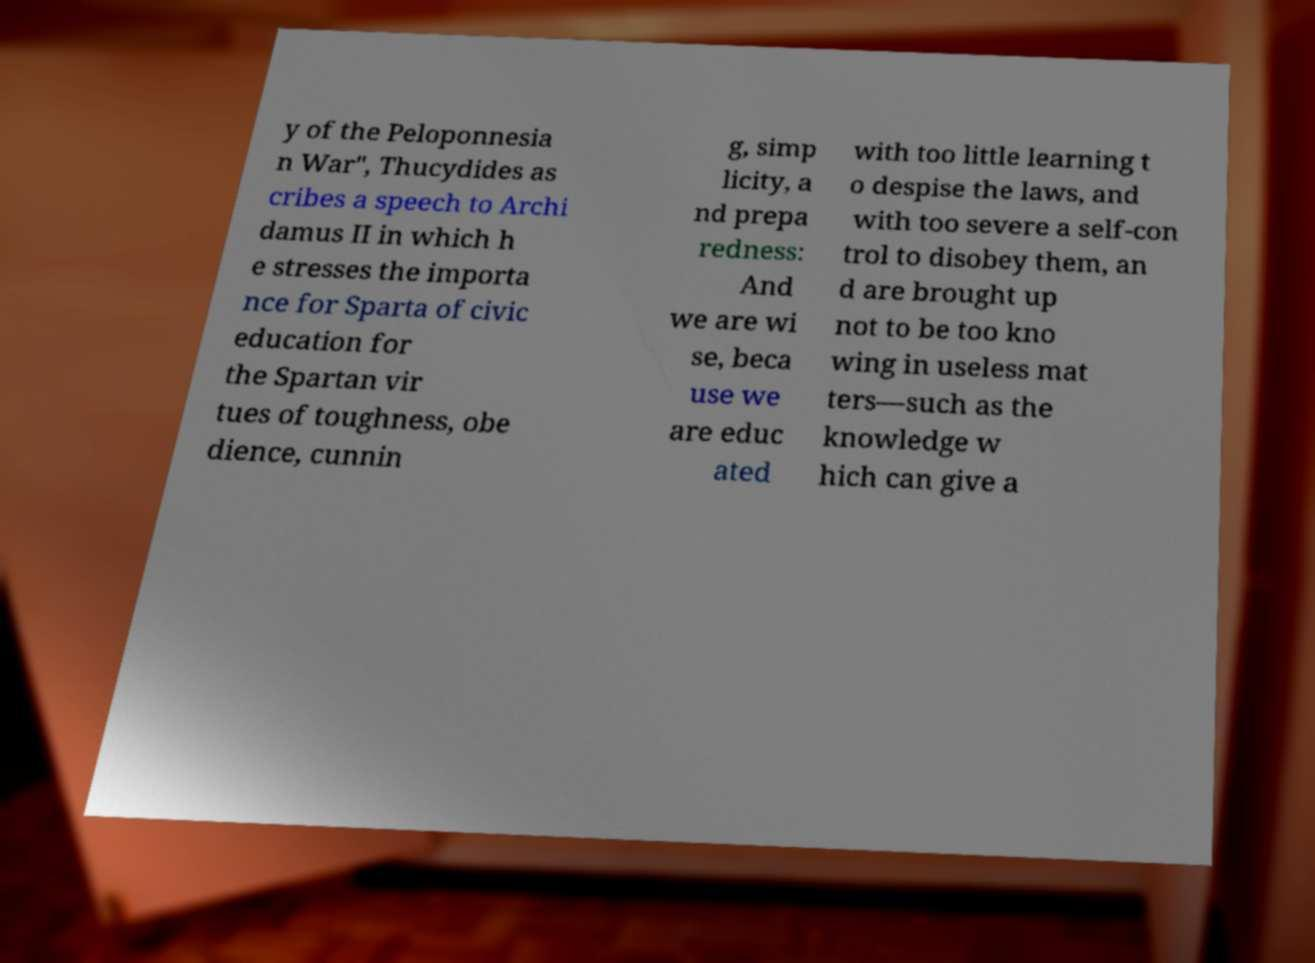Can you read and provide the text displayed in the image?This photo seems to have some interesting text. Can you extract and type it out for me? y of the Peloponnesia n War", Thucydides as cribes a speech to Archi damus II in which h e stresses the importa nce for Sparta of civic education for the Spartan vir tues of toughness, obe dience, cunnin g, simp licity, a nd prepa redness: And we are wi se, beca use we are educ ated with too little learning t o despise the laws, and with too severe a self-con trol to disobey them, an d are brought up not to be too kno wing in useless mat ters—such as the knowledge w hich can give a 